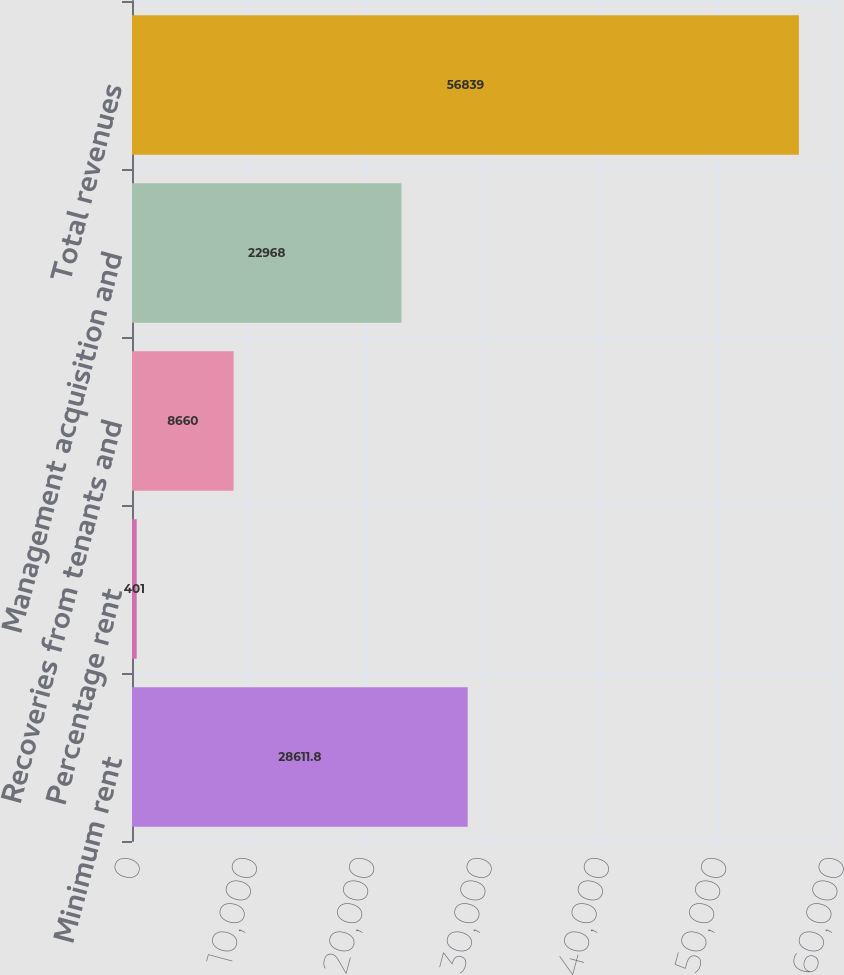Convert chart. <chart><loc_0><loc_0><loc_500><loc_500><bar_chart><fcel>Minimum rent<fcel>Percentage rent<fcel>Recoveries from tenants and<fcel>Management acquisition and<fcel>Total revenues<nl><fcel>28611.8<fcel>401<fcel>8660<fcel>22968<fcel>56839<nl></chart> 